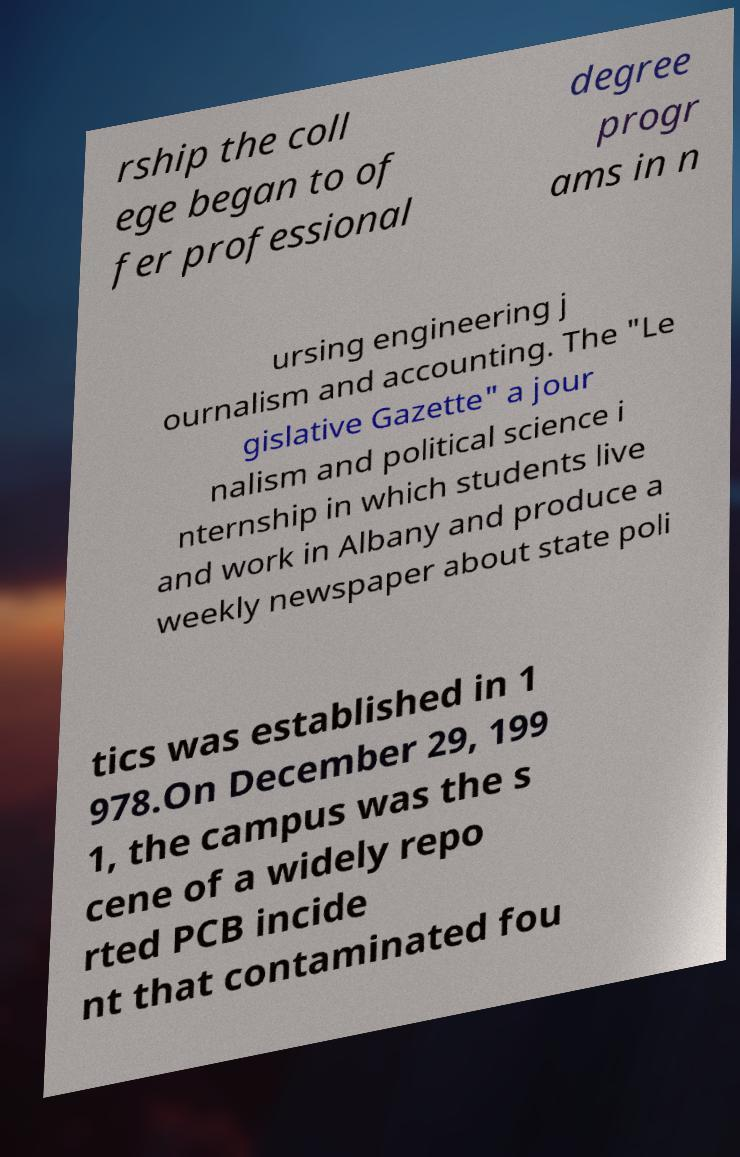Please identify and transcribe the text found in this image. rship the coll ege began to of fer professional degree progr ams in n ursing engineering j ournalism and accounting. The "Le gislative Gazette" a jour nalism and political science i nternship in which students live and work in Albany and produce a weekly newspaper about state poli tics was established in 1 978.On December 29, 199 1, the campus was the s cene of a widely repo rted PCB incide nt that contaminated fou 